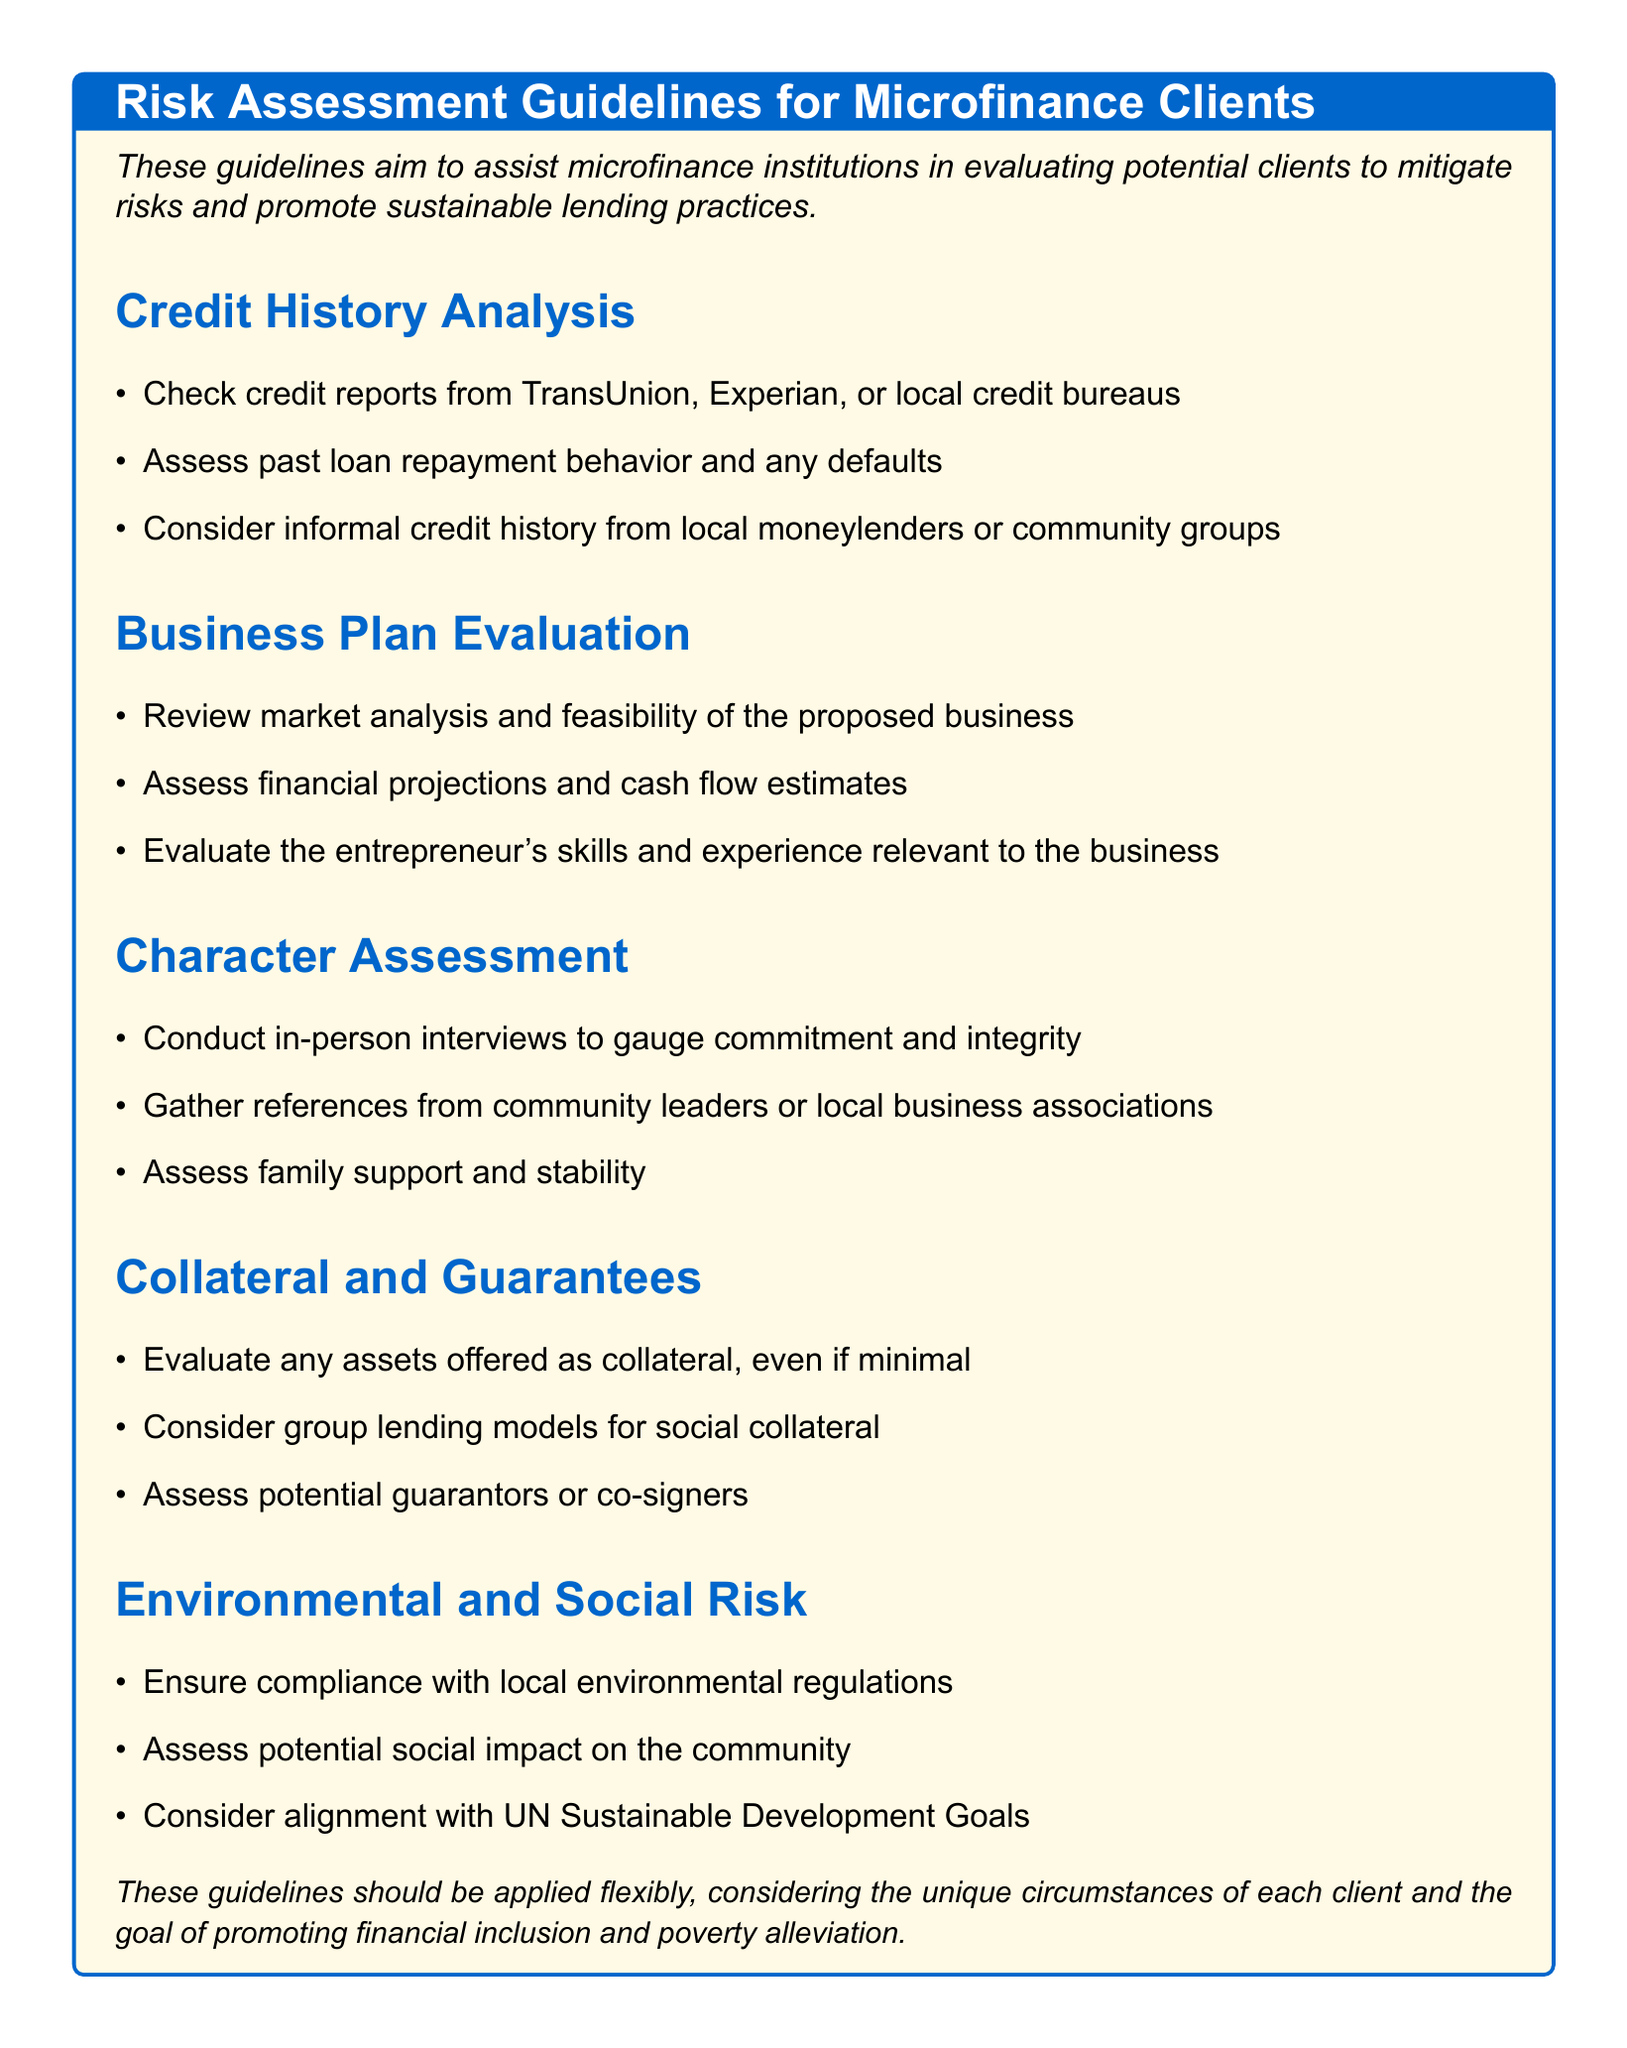What is the title of the document? The title is clearly stated at the beginning of the document.
Answer: Risk Assessment Guidelines for Microfinance Clients What are the three main areas of evaluation listed in the guidelines? The document lists specific sections that outline areas of evaluation.
Answer: Credit History Analysis, Business Plan Evaluation, Character Assessment What should be checked in the credit history analysis? The document specifies particular items to check in this section.
Answer: Credit reports What is one aspect of the business plan evaluation? One of the items listed under business plan evaluation is highlighted in the document.
Answer: Market analysis What type of assessments are included under Environmental and Social Risk? The document lists specific considerations for this section.
Answer: Compliance with local environmental regulations What is suggested as a part of character assessment? The document outlines approaches for assessing character.
Answer: In-person interviews What should be evaluated regarding collateral? The document provides guidance on this topic under collateral and guarantees.
Answer: Any assets offered as collateral What sustainable consideration is mentioned in the guidelines? A specific mention in the document relates to sustainability initiatives.
Answer: UN Sustainable Development Goals How are loans proposed to be mitigated in risk? The document outlines a flexible application of the guidelines to achieve a certain goal.
Answer: Promoting financial inclusion and poverty alleviation 